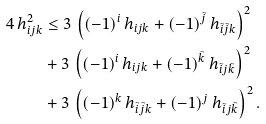Convert formula to latex. <formula><loc_0><loc_0><loc_500><loc_500>4 \, h _ { i j k } ^ { 2 } & \leq 3 \, \left ( ( - 1 ) ^ { i } \, h _ { i j k } + ( - 1 ) ^ { \tilde { j } } \, h _ { \tilde { i } \tilde { j } k } \right ) ^ { 2 } \\ & + 3 \, \left ( ( - 1 ) ^ { i } \, h _ { i j k } + ( - 1 ) ^ { \tilde { k } } \, h _ { \tilde { i } j \tilde { k } } \right ) ^ { 2 } \\ & + 3 \, \left ( ( - 1 ) ^ { k } \, h _ { \tilde { i } \tilde { j } k } + ( - 1 ) ^ { j } \, h _ { \tilde { i } j \tilde { k } } \right ) ^ { 2 } .</formula> 